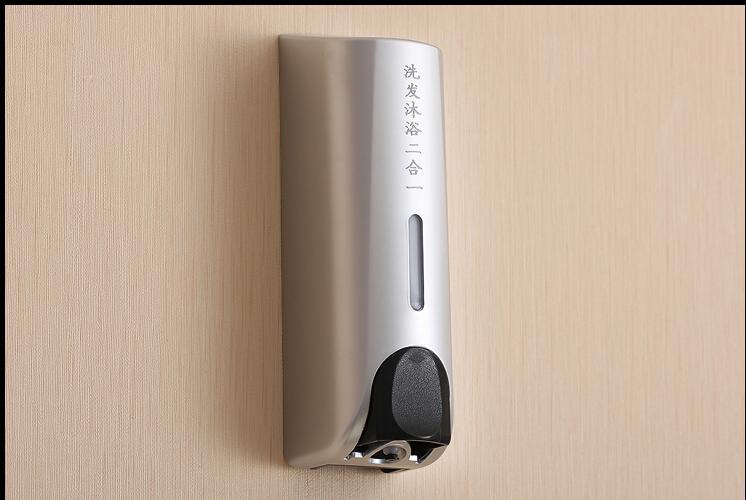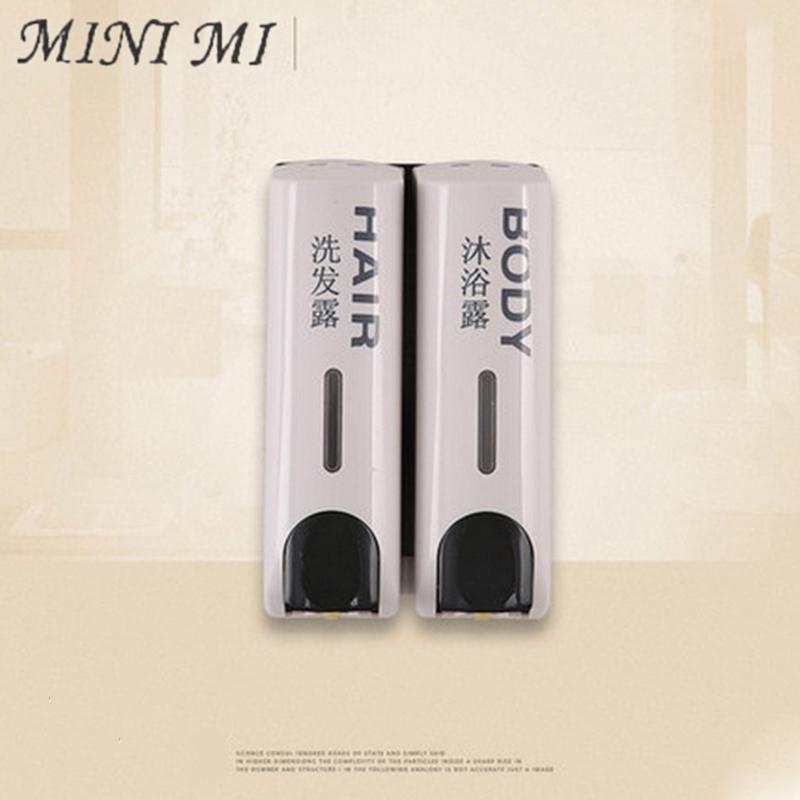The first image is the image on the left, the second image is the image on the right. Considering the images on both sides, is "An image shows side-by-side dispensers with black dispenser 'buttons'." valid? Answer yes or no. Yes. The first image is the image on the left, the second image is the image on the right. For the images displayed, is the sentence "Exactly three wall mounted bathroom dispensers are shown, with two matching dispensers in one image and different third dispenser in the other image." factually correct? Answer yes or no. Yes. 